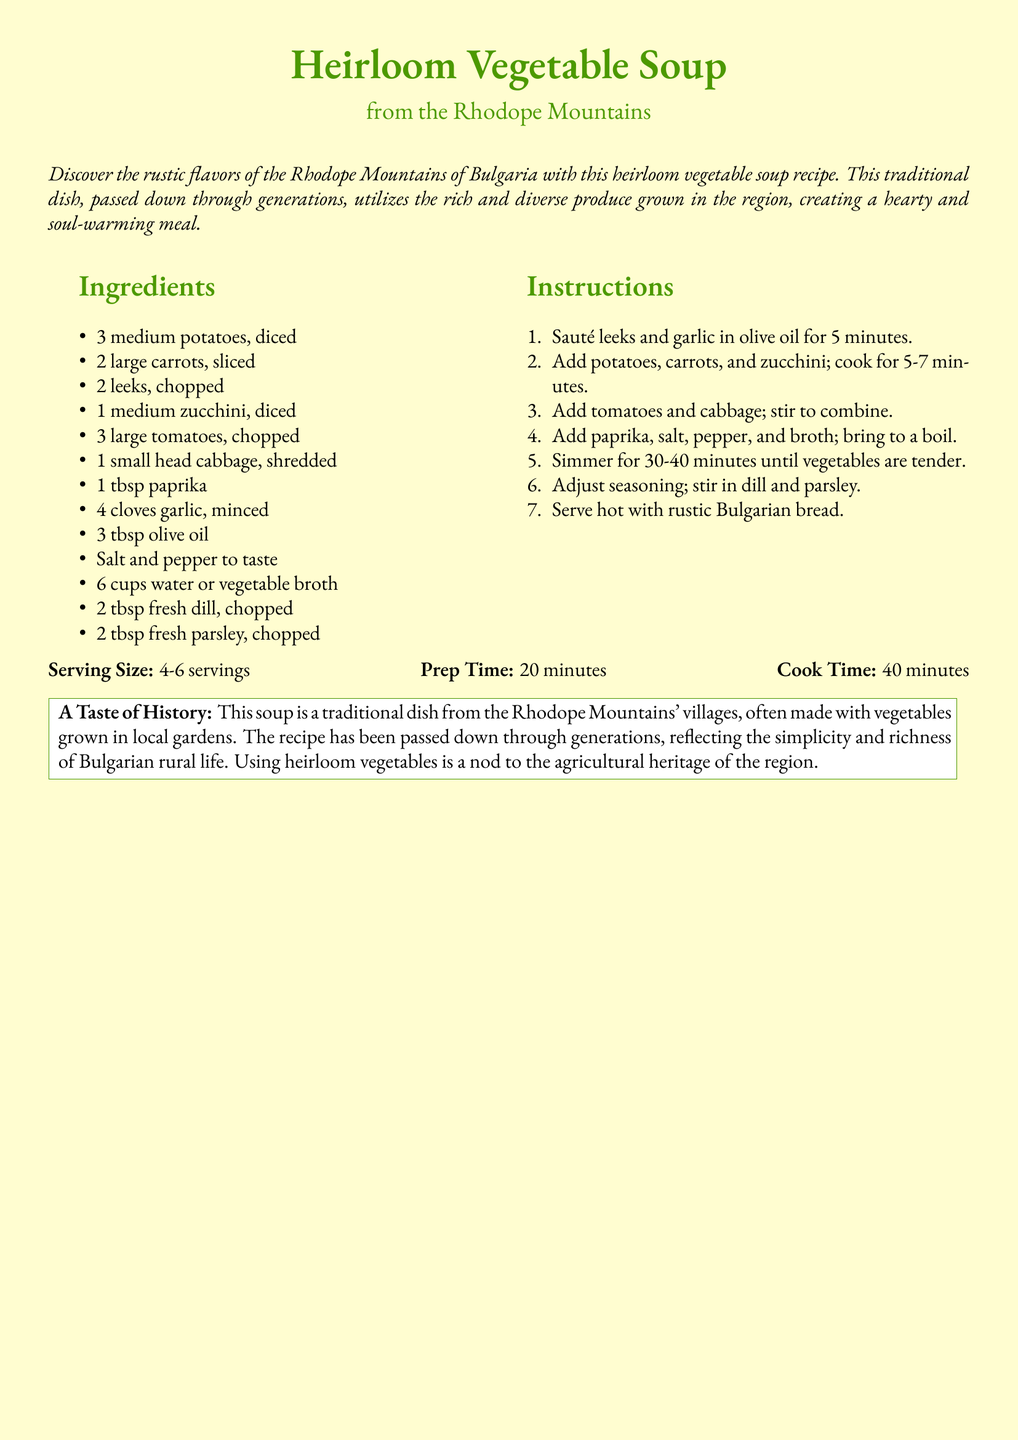What is the main ingredient used for the soup? The main ingredients are listed as potatoes, carrots, leeks, zucchini, tomatoes, and cabbage in the recipe.
Answer: Heirloom vegetables What is the serving size for the soup? The serving size is mentioned at the end of the ingredients and instructions section.
Answer: 4-6 servings How long is the prep time? The prep time is specified in the serving details of the recipe card.
Answer: 20 minutes From which region does the recipe originate? The document states that the recipe comes from the Rhodope Mountains of Bulgaria.
Answer: Rhodope Mountains How many cloves of garlic are needed? The number of cloves of garlic is indicated in the ingredients section of the document.
Answer: 4 cloves What is the cook time required for the soup? The cook time is mentioned alongside the prep time in the serving details.
Answer: 40 minutes What type of bread is recommended to serve with the soup? The recommendation for bread type is provided at the end of the instructions.
Answer: Rustic Bulgarian bread What colors are associated with the document design? The document mentions specific colors used, such as "rhodope" and "parchment."
Answer: Rhodope and parchment What is the purpose of using heirloom vegetables in the recipe? The document explains that using heirloom vegetables reflects agricultural heritage and richness of rural life.
Answer: Agricultural heritage 